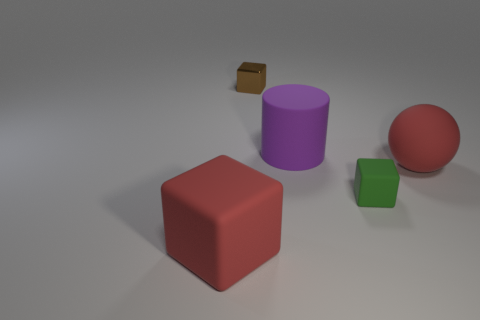How many objects are in the image, and can you describe them? There are four objects in the image: a red rubber ball with a glossy surface, a purple cylinder that's standing upright, a green cube that's smaller in size, and a small brown box in the background. 